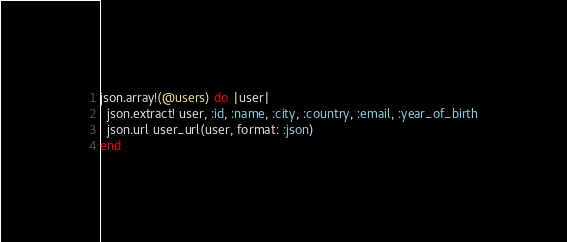<code> <loc_0><loc_0><loc_500><loc_500><_Ruby_>json.array!(@users) do |user|
  json.extract! user, :id, :name, :city, :country, :email, :year_of_birth
  json.url user_url(user, format: :json)
end
</code> 